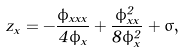Convert formula to latex. <formula><loc_0><loc_0><loc_500><loc_500>z _ { x } = - \frac { \phi _ { x x x } } { 4 \phi _ { x } } + \frac { \phi _ { x x } ^ { 2 } } { 8 \phi _ { x } ^ { 2 } } + \sigma ,</formula> 